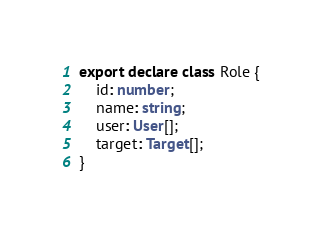<code> <loc_0><loc_0><loc_500><loc_500><_TypeScript_>export declare class Role {
    id: number;
    name: string;
    user: User[];
    target: Target[];
}
</code> 